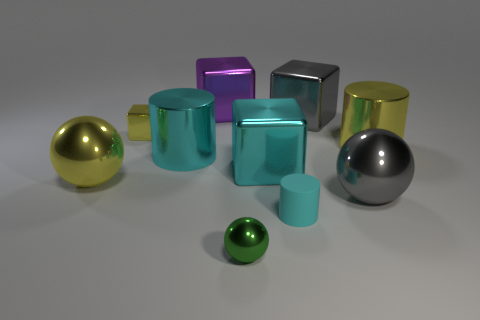Are there more metallic things left of the tiny metallic block than small cyan objects?
Make the answer very short. No. There is a purple cube that is the same material as the big yellow cylinder; what size is it?
Give a very brief answer. Large. There is a small shiny ball; are there any yellow metal cylinders behind it?
Provide a succinct answer. Yes. Is the shape of the small green thing the same as the small cyan object?
Keep it short and to the point. No. There is a yellow object that is on the left side of the small metal thing behind the tiny metal thing to the right of the purple metal object; how big is it?
Provide a short and direct response. Large. What is the yellow ball made of?
Make the answer very short. Metal. The other cylinder that is the same color as the matte cylinder is what size?
Make the answer very short. Large. There is a green object; is it the same shape as the big gray thing right of the big gray cube?
Provide a short and direct response. Yes. There is a large cylinder to the left of the large gray thing behind the large yellow object that is left of the tiny cyan object; what is it made of?
Ensure brevity in your answer.  Metal. What number of large yellow objects are there?
Offer a terse response. 2. 